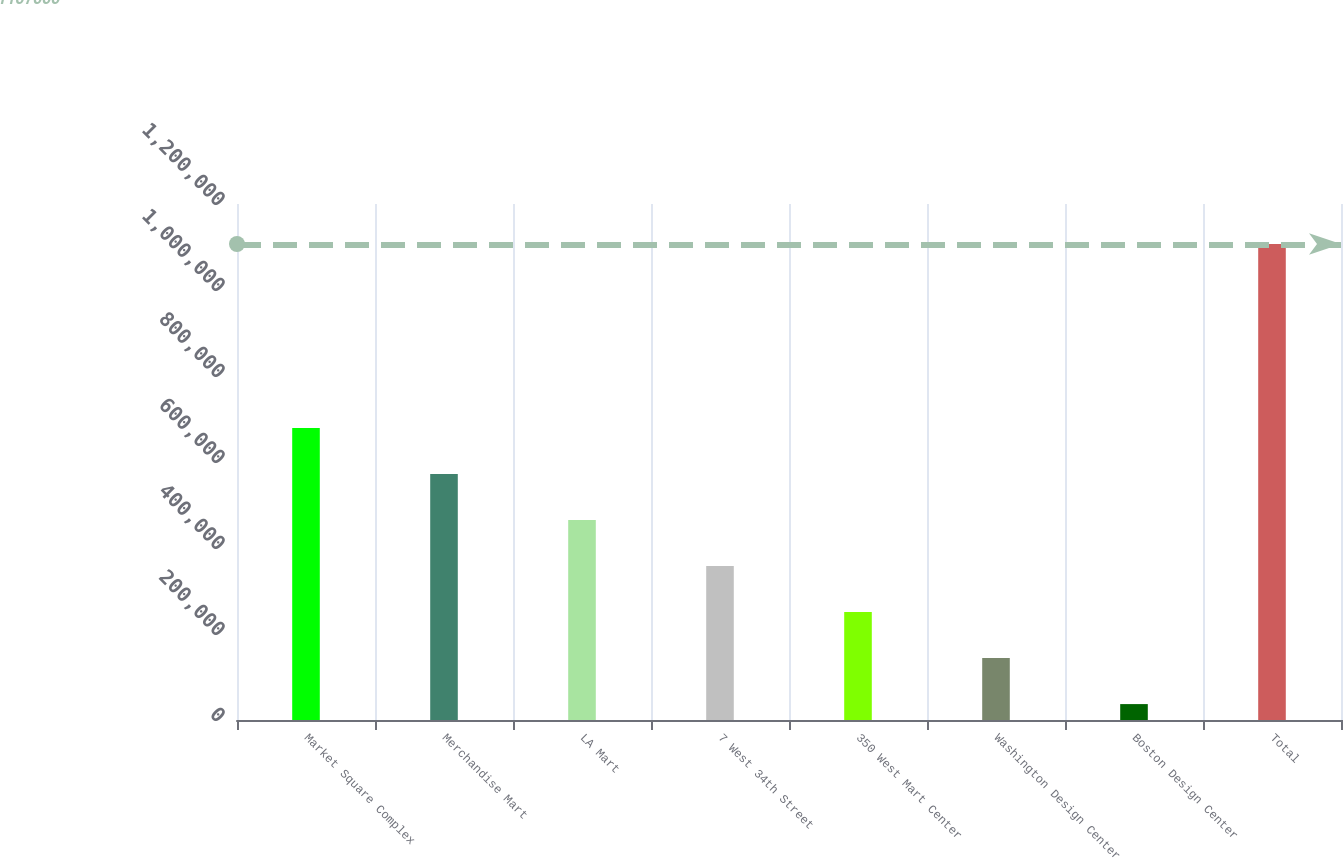Convert chart to OTSL. <chart><loc_0><loc_0><loc_500><loc_500><bar_chart><fcel>Market Square Complex<fcel>Merchandise Mart<fcel>LA Mart<fcel>7 West 34th Street<fcel>350 West Mart Center<fcel>Washington Design Center<fcel>Boston Design Center<fcel>Total<nl><fcel>679000<fcel>572000<fcel>465000<fcel>358000<fcel>251000<fcel>144000<fcel>37000<fcel>1.107e+06<nl></chart> 